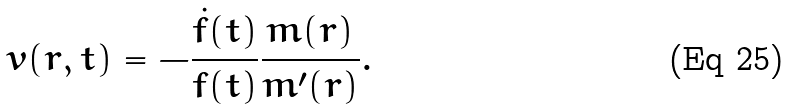<formula> <loc_0><loc_0><loc_500><loc_500>v ( r , t ) = - \frac { \dot { f } ( t ) } { f ( t ) } \frac { m ( r ) } { m ^ { \prime } ( r ) } .</formula> 